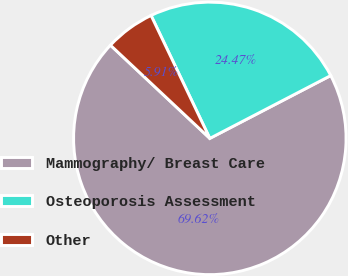Convert chart to OTSL. <chart><loc_0><loc_0><loc_500><loc_500><pie_chart><fcel>Mammography/ Breast Care<fcel>Osteoporosis Assessment<fcel>Other<nl><fcel>69.61%<fcel>24.47%<fcel>5.91%<nl></chart> 